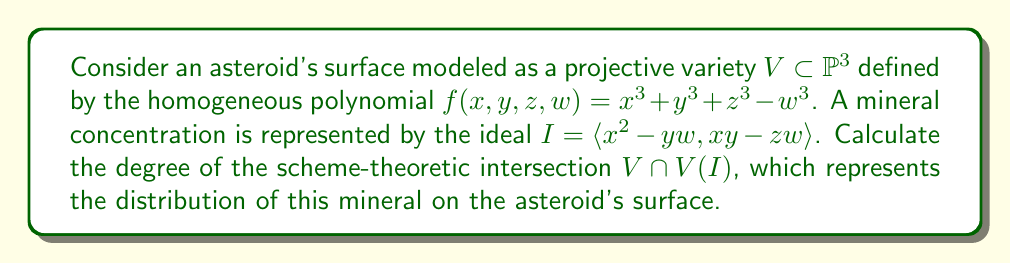Solve this math problem. 1) First, we need to understand that the degree of the scheme-theoretic intersection is given by Bézout's theorem when applied properly.

2) The degree of $V$ is 3, as it's defined by a homogeneous polynomial of degree 3.

3) The ideal $I$ is generated by two polynomials, each of degree 2. Therefore, $V(I)$ is the intersection of two quadric surfaces in $\mathbb{P}^3$.

4) By Bézout's theorem, the degree of $V(I)$ is $2 \cdot 2 = 4$.

5) Now, we need to find the degree of $V \cap V(I)$. This is the intersection of a cubic surface (degree 3) with a curve of degree 4.

6) Applying Bézout's theorem again, the degree of the intersection is:

   $\deg(V) \cdot \deg(V(I)) = 3 \cdot 4 = 12$

7) Therefore, the scheme-theoretic intersection $V \cap V(I)$ has degree 12.

This degree represents the number of points (counting multiplicity) where the mineral concentration meets the asteroid's surface model, giving us a measure of the mineral's distribution.
Answer: 12 